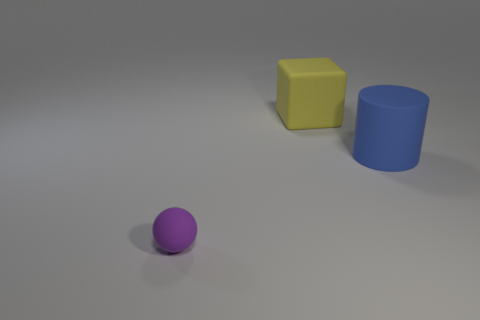Add 3 spheres. How many objects exist? 6 Subtract 0 blue spheres. How many objects are left? 3 Subtract all blocks. How many objects are left? 2 Subtract 1 blocks. How many blocks are left? 0 Subtract all red cylinders. Subtract all gray blocks. How many cylinders are left? 1 Subtract all big blue cylinders. Subtract all small purple balls. How many objects are left? 1 Add 1 small purple rubber objects. How many small purple rubber objects are left? 2 Add 2 big gray things. How many big gray things exist? 2 